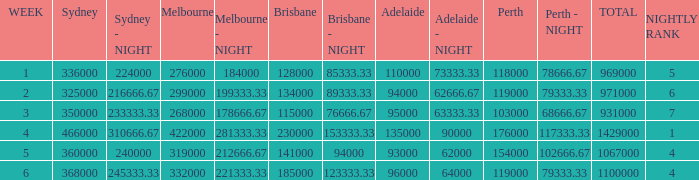What was the total rating on week 3?  931000.0. 